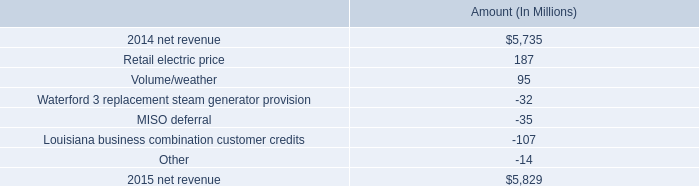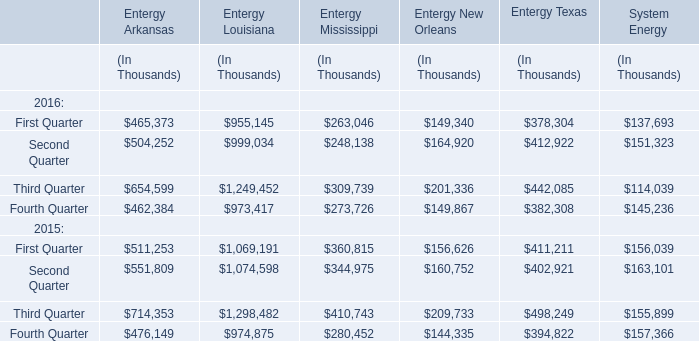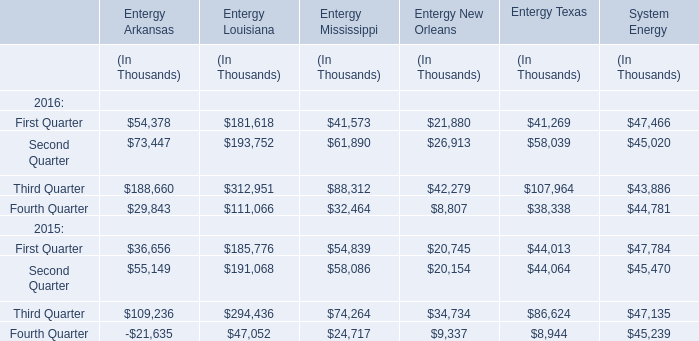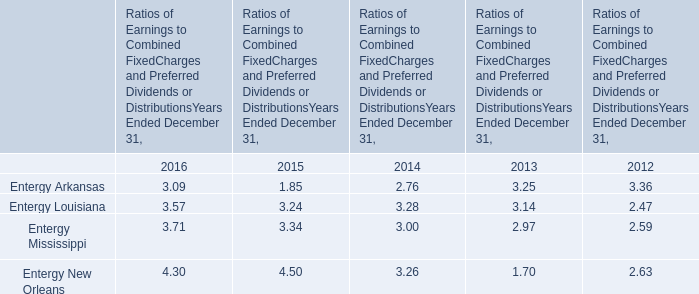What is the average increasing rate of Entergy Arkansas in First Quarter between 2015 and 2016? 
Computations: ((54378 - 36656) / 36656)
Answer: 0.48347. 